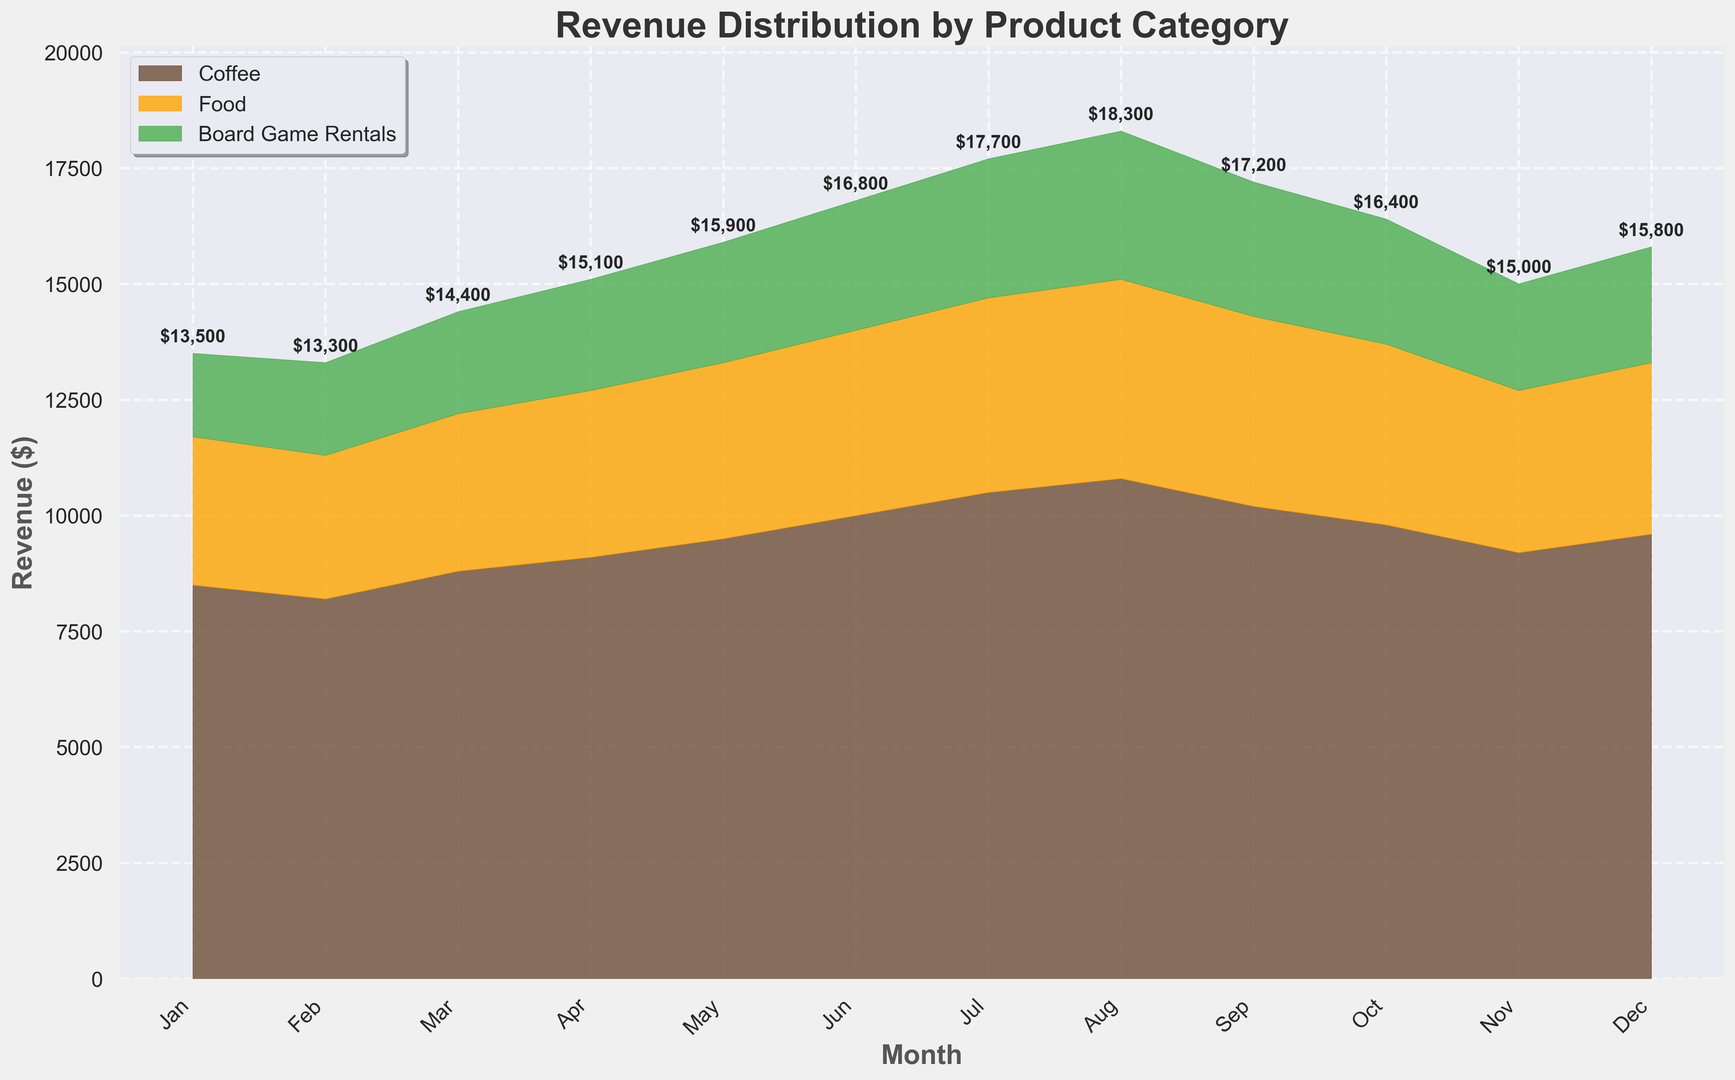How did the revenue from board game rentals change from January to December? To find the change in revenue from board game rentals between January and December, look at the height of the green area for these two months. In January, it is $1800, and in December, it is $2500. Subtract the January value from the December value to determine the change: $2500 - $1800 = $700.
Answer: $700 Which product category had the highest increase in revenue over the year? First, calculate the revenue increase for each category by subtracting the January value from the December value. Coffee: $9600 - $8500 = $1100, Food: $3700 - $3200 = $500, Board Game Rentals: $2500 - $1800 = $700. Among these values, Coffee has the highest increase of $1100.
Answer: Coffee What is the combined revenue for Coffee and Food in June? To find the combined revenue for Coffee and Food in June, add the June values for each category. Coffee is $10000 and Food is $4000. Therefore, $10000 + $4000 = $14000.
Answer: $14000 In which month did Food revenue first surpass $3500? Locate the point on the orange area where Food revenue first surpasses $3500. By observing the figure, Food revenue surpasses $3500 in May.
Answer: May Which month had the lowest total revenue? To determine the month with the lowest total revenue, sum the revenues for Coffee, Food, and Board Game Rentals for each month and identify the smallest total. Jan: $13500, Feb: $13300, Mar: $14400, Apr: $15100, May: $15900, Jun: $16800, Jul: $17700, Aug: $18300, Sep: $17200, Oct: $16400, Nov: $15000, Dec: $15800. February has the lowest total revenue of $13300.
Answer: February How does the revenue of Coffee in March compare to that of Food and Board Game Rentals combined in the same month? Coffee revenue in March is $8800. Combined Food and Board Game Rentals revenue in March is $3400 + $2200 = $5600. Comparing $8800 (Coffee) to $5600 (Food + Board Game Rentals), Coffee revenue is higher by $8800 - $5600 = $3200.
Answer: Coffee revenue is higher by $3200 Which category contributed the most to the total revenue in November? To determine which category contributed the most in November, compare the heights of the respective areas. Coffee: $9200, Food: $3500, Board Game Rentals: $2300. Coffee contributes the most with $9200.
Answer: Coffee What is the overall trend for Board Game Rentals revenue over the year? Observe the green area across the months. Board Game Rentals revenue has a general upward trend starting at $1800 in January and increasing to $2500 in December.
Answer: Upward trend What was the total revenue in the highest revenue month, and which month was it? To find the highest total revenue month, sum the revenues for each month and identify the highest total. Jul: $17700.
Answer: July, $17700 By how much did the combined revenue of Coffee and Board Game Rentals increase from March to August? To find the increase, first find the combined revenue for each month. March: $8800 (Coffee) + $2200 (Board Game Rentals) = $11000, August: $10800 (Coffee) + $3200 (Board Game Rentals) = $14000. The increase is $14000 - $11000 = $3000.
Answer: $3000 